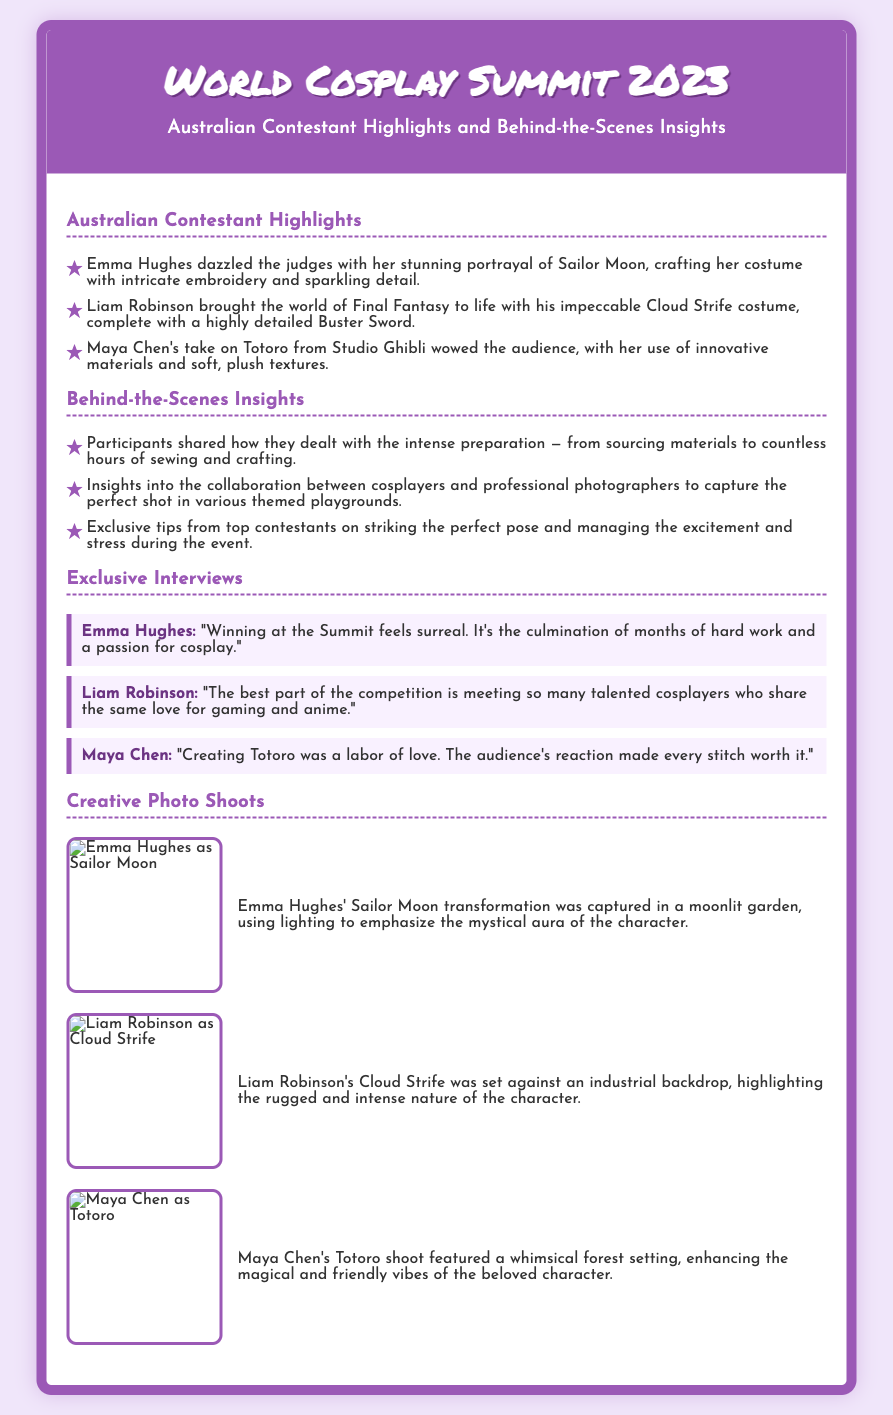What character did Emma Hughes portray? Emma Hughes dazzled the judges with her portrayal of Sailor Moon, as stated in the document.
Answer: Sailor Moon Who created a costume of Cloud Strife? Liam Robinson brought the world of Final Fantasy to life with his Cloud Strife costume, as highlighted in the document.
Answer: Liam Robinson What innovative materials did Maya Chen use? Maya Chen's take on Totoro featured innovative materials, mentioned in the highlights section.
Answer: Innovative materials What backdrop was used for Liam Robinson's photo shoot? Liam Robinson's Cloud Strife was set against an industrial backdrop, as described in the creative photo shoots section.
Answer: Industrial backdrop How many contestants are highlighted in the document? Three contestants are mentioned: Emma Hughes, Liam Robinson, and Maya Chen; thus, the total number is three.
Answer: Three What was Emma Hughes's feeling about winning? Emma Hughes described winning as "surreal", reflecting her emotions in the interview section.
Answer: Surreal Which character did Maya Chen create? Maya Chen's character creation was Totoro, as mentioned in the highlights.
Answer: Totoro What type of insights are provided in the document? The document provides "Behind-the-Scenes Insights" as a specific type of content feature.
Answer: Behind-the-Scenes Insights 